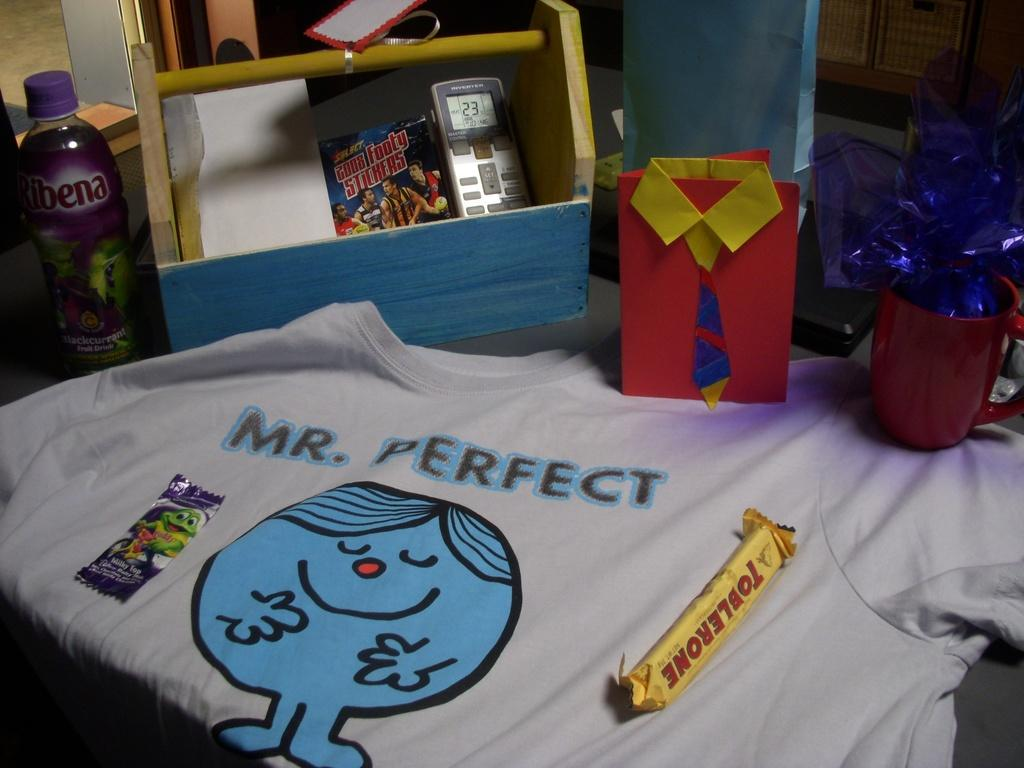<image>
Share a concise interpretation of the image provided. A t shirt with a blue cartoonish character and Mr. Perfect on top. 